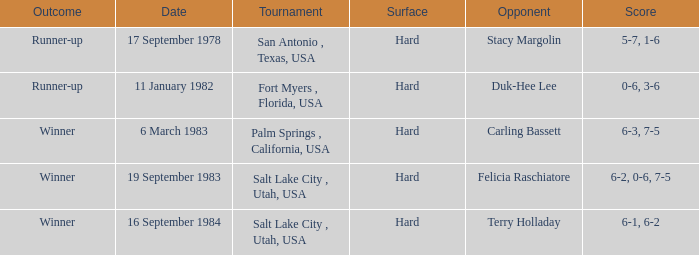I'm looking to parse the entire table for insights. Could you assist me with that? {'header': ['Outcome', 'Date', 'Tournament', 'Surface', 'Opponent', 'Score'], 'rows': [['Runner-up', '17 September 1978', 'San Antonio , Texas, USA', 'Hard', 'Stacy Margolin', '5-7, 1-6'], ['Runner-up', '11 January 1982', 'Fort Myers , Florida, USA', 'Hard', 'Duk-Hee Lee', '0-6, 3-6'], ['Winner', '6 March 1983', 'Palm Springs , California, USA', 'Hard', 'Carling Bassett', '6-3, 7-5'], ['Winner', '19 September 1983', 'Salt Lake City , Utah, USA', 'Hard', 'Felicia Raschiatore', '6-2, 0-6, 7-5'], ['Winner', '16 September 1984', 'Salt Lake City , Utah, USA', 'Hard', 'Terry Holladay', '6-1, 6-2']]} What was the score of the match against duk-hee lee? 0-6, 3-6. 